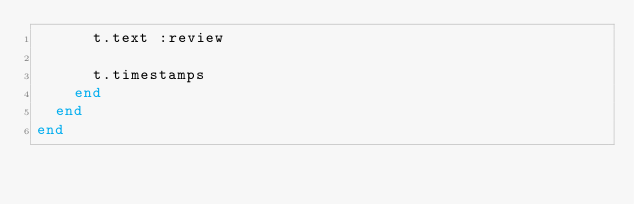Convert code to text. <code><loc_0><loc_0><loc_500><loc_500><_Ruby_>      t.text :review

      t.timestamps
    end
  end
end
</code> 